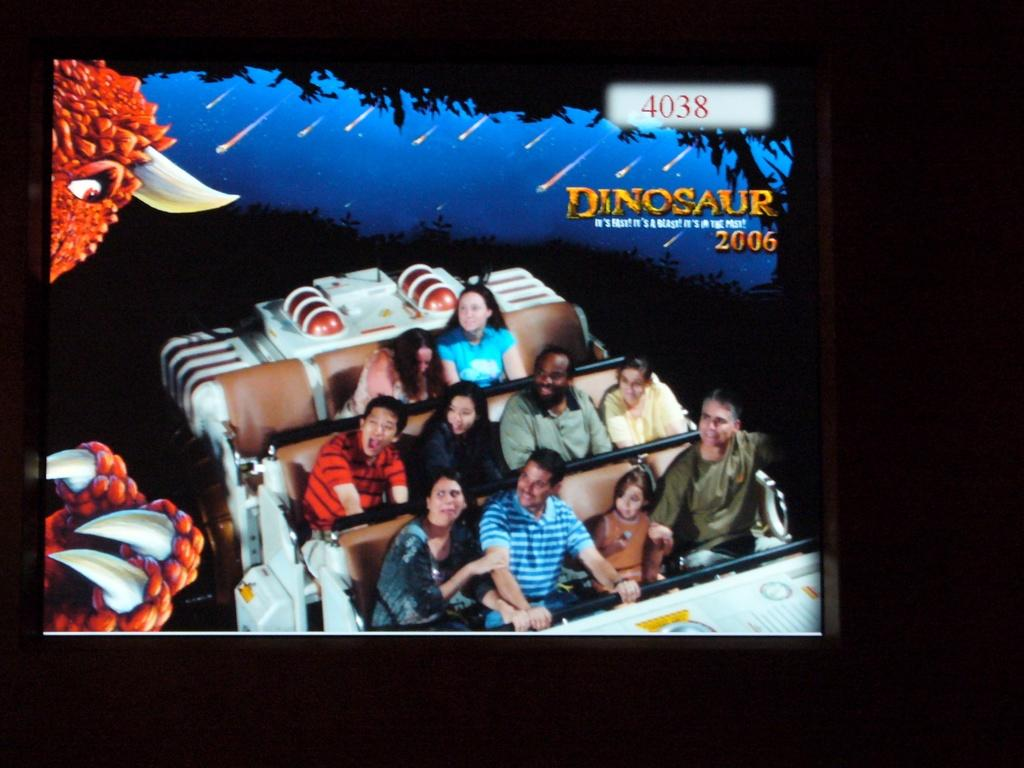<image>
Give a short and clear explanation of the subsequent image. a picture of people on a Dinosaur ride with number 4038 on it 